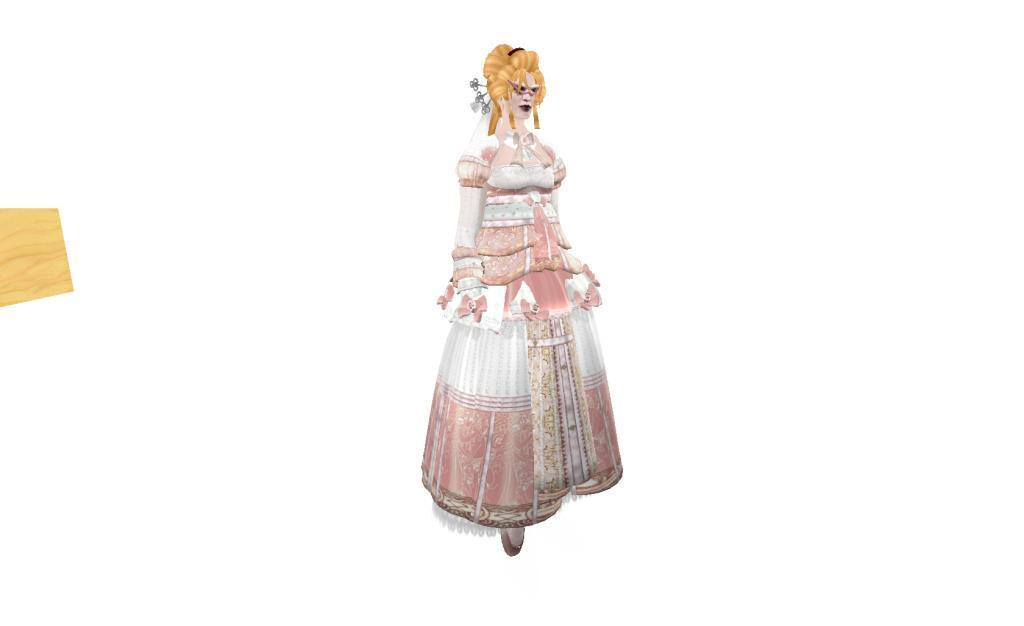Who is present in the image? There is a woman in the image. What is the woman wearing? The woman is wearing a dress. What can be seen on the left side of the image? There is an object on the left side of the image. What is the color of the background in the image? The background of the image is in white color. What is the woman's opinion on the drawer in the image? There is no drawer present in the image, so it is not possible to determine the woman's opinion on it. 